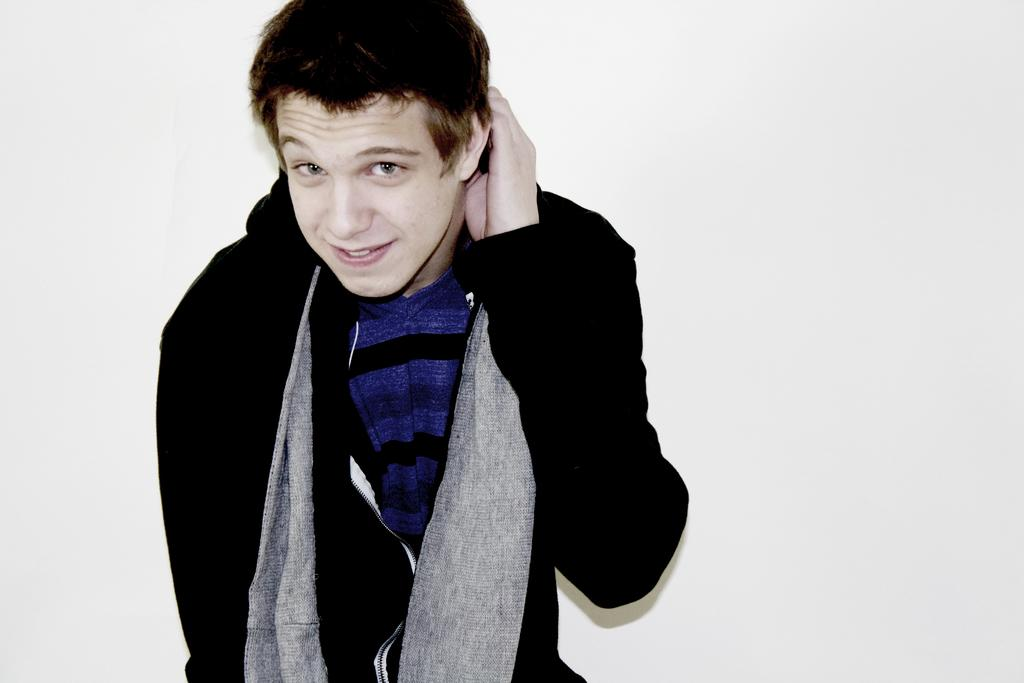What is the main subject of the image? There is a man in the image. Where is the man positioned in the image? The man is standing in the center of the image. What expression does the man have? The man is smiling. What type of quiver can be seen on the man's back in the image? There is no quiver present on the man's back in the image. How many cows are visible in the image? There are no cows visible in the image; it features a man standing in the center. 